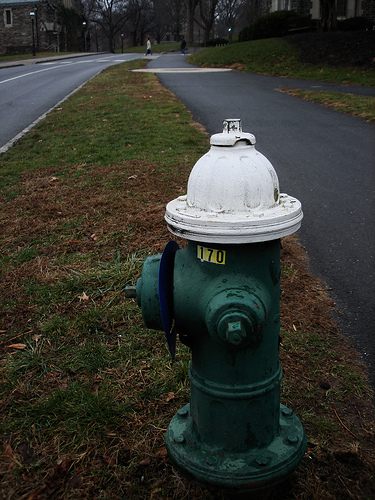Please provide the bounding box coordinate of the region this sentence describes: person walking on the road. The approximate region where a person is walking on the road is defined by coordinates [0.4, 0.07, 0.44, 0.11], nicely capturing the pedestrian’s movement in a residential area. 